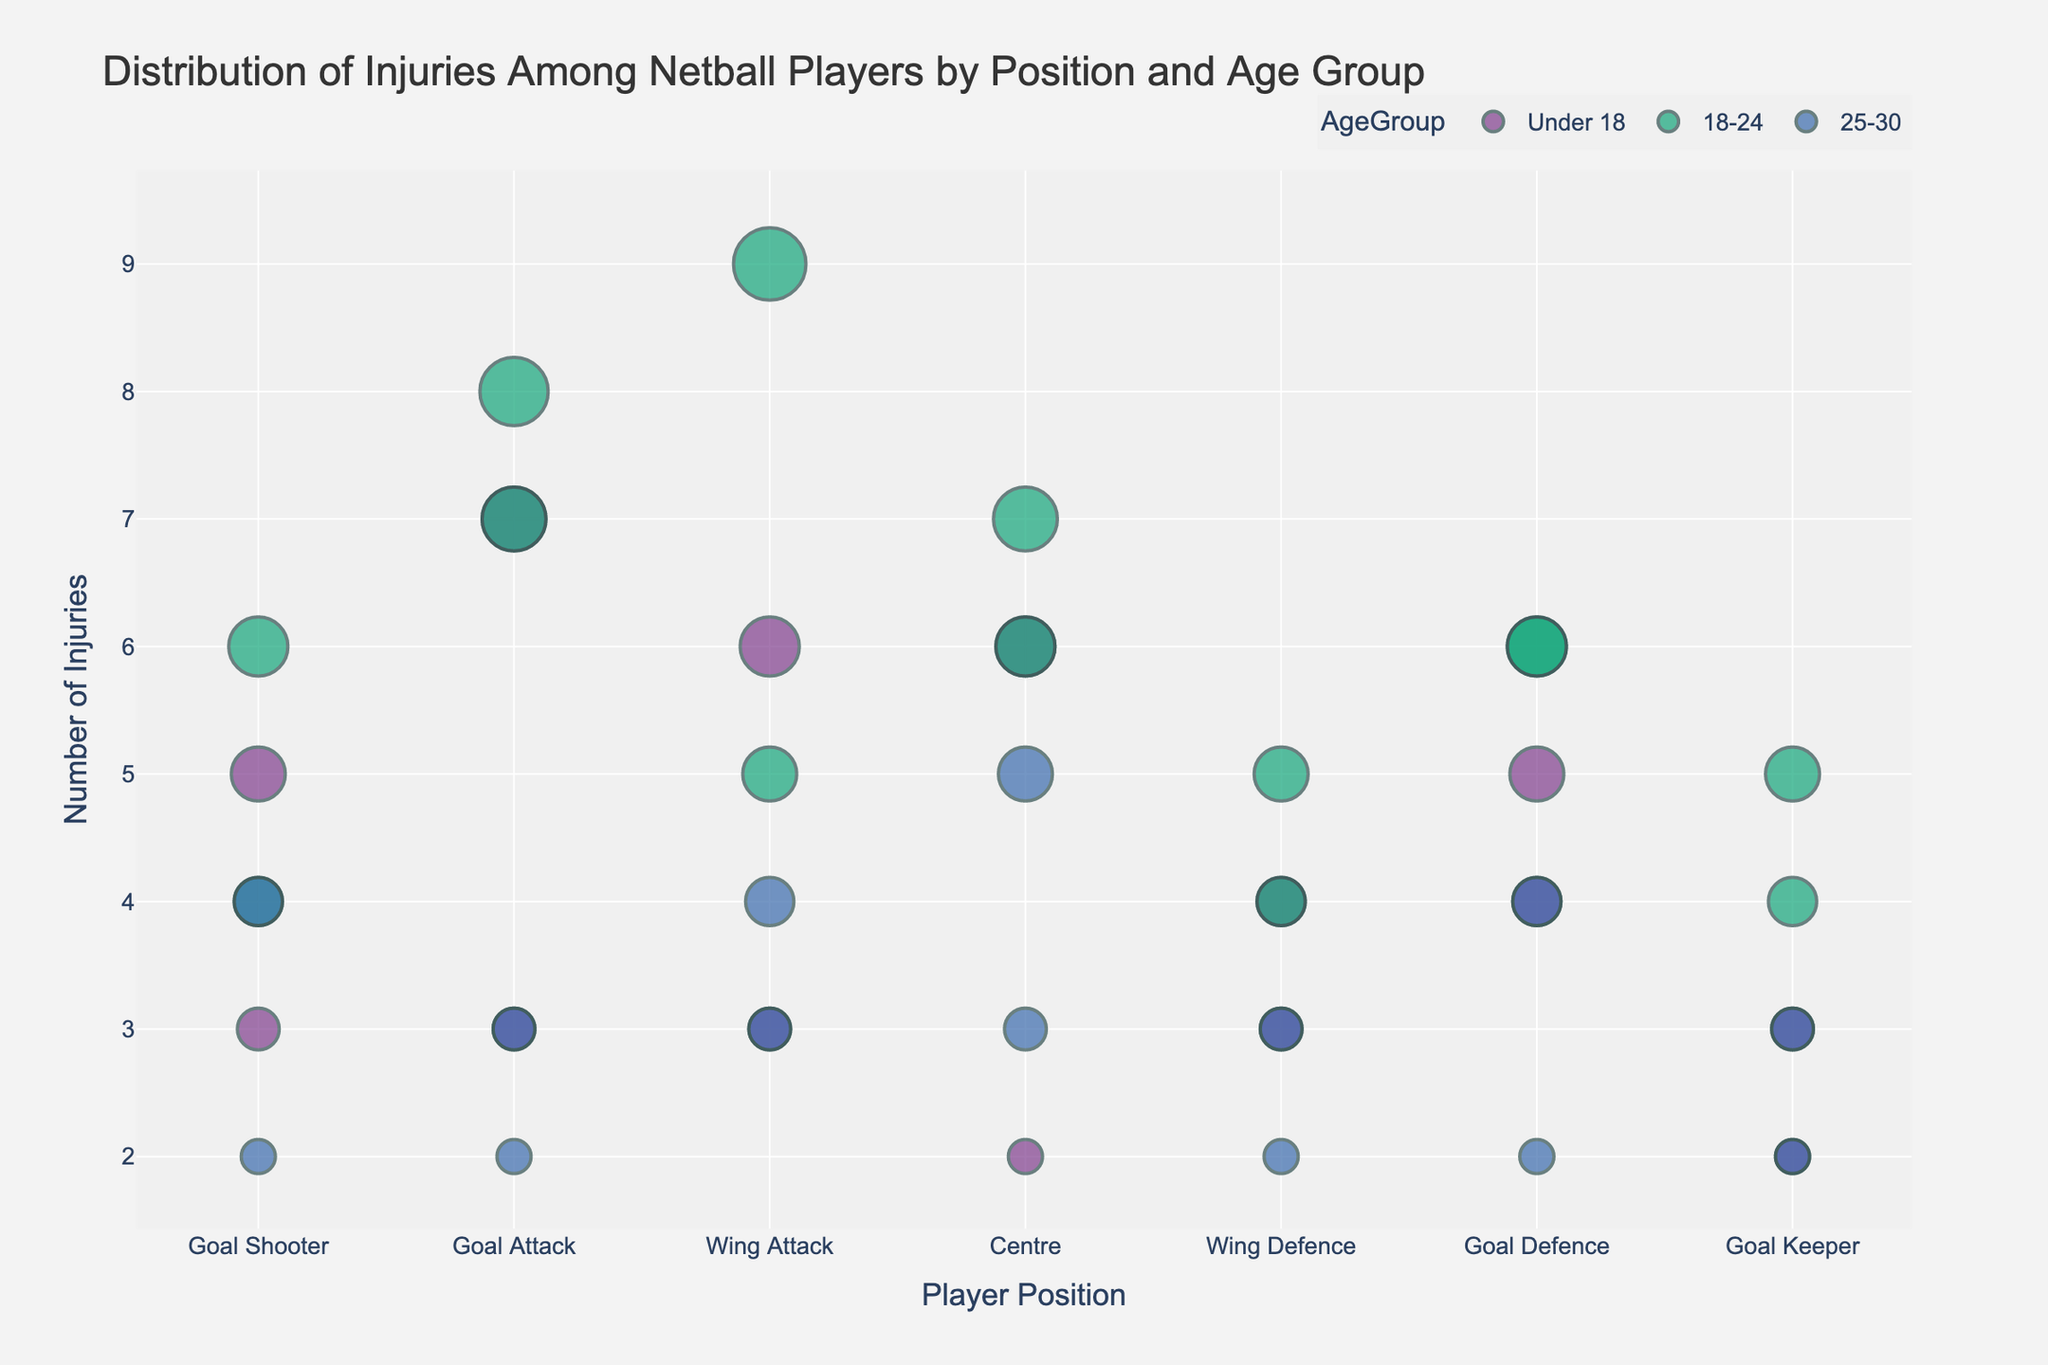What is the title of the plot? The title of the plot is written at the top and it reads "Distribution of Injuries Among Netball Players by Position and Age Group".
Answer: Distribution of Injuries Among Netball Players by Position and Age Group How is the size of the data points determined in the scatter plot? The size of the data points represents the number of injuries, with larger points indicating a higher count of injuries.
Answer: Number of injuries Which player position has the most injury types represented among all age groups? By looking at the scatter plot, Wing Attack position shows the most diverse injury types across different age groups.
Answer: Wing Attack Which age group has the highest number of injuries for Goal Attack position? For Goal Attack position, the scatter plot shows that the 18-24 age group has the largest size data points, indicating the highest number of injuries.
Answer: 18-24 How many types of injuries are recorded for the Centre position? Counting the different injury types represented for the Centre position indicates there are four types: Ankle Sprain, Concussion, Knee Injury, and Back Strain.
Answer: Four Compare the number of Ankle Sprains recorded for players under 18 across different positions. Which position has the highest count? By comparing the sizes of data points for Ankle Sprain under the under 18 age group, Goal Attack has the most with a count of 7.
Answer: Goal Attack Which injury type for the Wing Defence position shows up in the 18-24 age group most frequently? For Wing Defence and 18-24 age group, the largest data point size is for Ankle Sprain, indicating it is the most frequent injury type.
Answer: Ankle Sprain What is the total number of ACL Tear injuries for players in the 25-30 age group across all positions? Adding the counts of ACL Tear injuries for the 25-30 age group from the scatter plot, Wing Attack 4, Centre 0, Wing Defence 0, Goal Defence 0, Goal Keeper 0, totals to 4.
Answer: 4 In the Goal Shooter position, which age group has the highest number of knee injuries? For Goal Shooter, the 18-24 age group has the larger data point for knee injuries, showing the highest number.
Answer: 18-24 Which position has the least number of injuries recorded for the under 18 age group? By comparing the size of data points for the under 18 age group, Goal Keeper has the least number of injuries.
Answer: Goal Keeper 